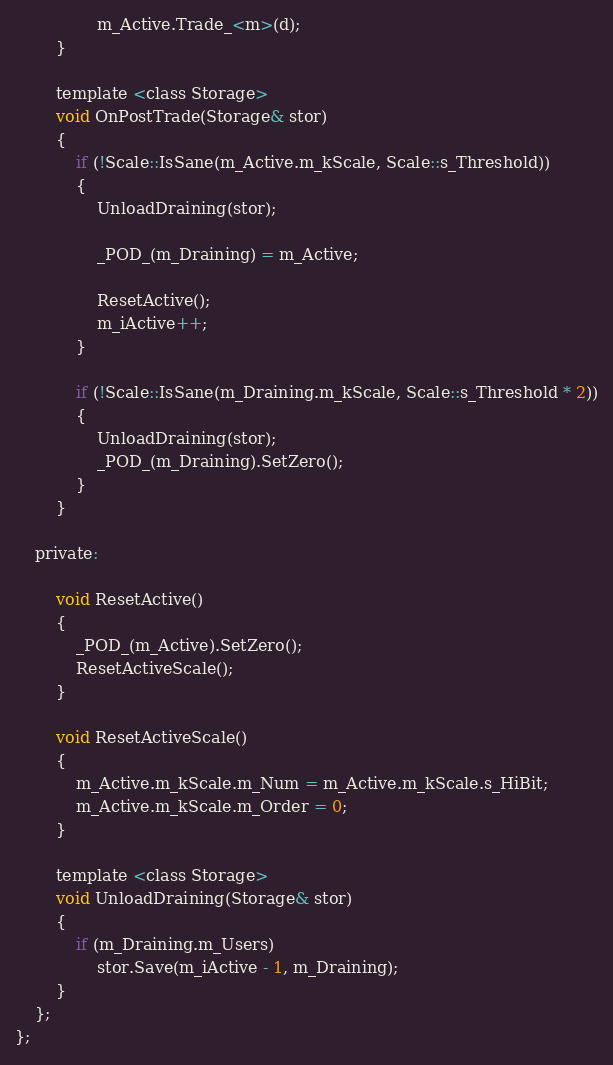Convert code to text. <code><loc_0><loc_0><loc_500><loc_500><_C_>                m_Active.Trade_<m>(d);
        }

        template <class Storage>
        void OnPostTrade(Storage& stor)
        {
            if (!Scale::IsSane(m_Active.m_kScale, Scale::s_Threshold))
            {
                UnloadDraining(stor);

                _POD_(m_Draining) = m_Active;

                ResetActive();
                m_iActive++;
            }

            if (!Scale::IsSane(m_Draining.m_kScale, Scale::s_Threshold * 2))
            {
                UnloadDraining(stor);
                _POD_(m_Draining).SetZero();
            }
        }

    private:

        void ResetActive()
        {
            _POD_(m_Active).SetZero();
            ResetActiveScale();
        }

        void ResetActiveScale()
        {
            m_Active.m_kScale.m_Num = m_Active.m_kScale.s_HiBit;
            m_Active.m_kScale.m_Order = 0;
        }

        template <class Storage>
        void UnloadDraining(Storage& stor)
        {
            if (m_Draining.m_Users)
                stor.Save(m_iActive - 1, m_Draining);
        }
    };
};
</code> 